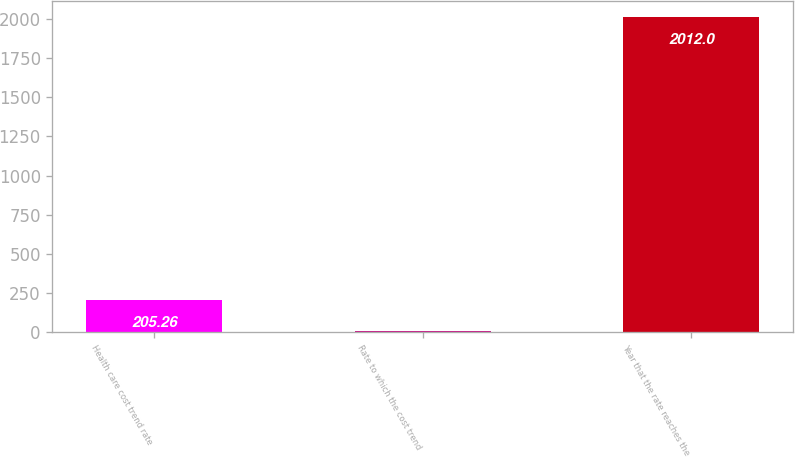Convert chart to OTSL. <chart><loc_0><loc_0><loc_500><loc_500><bar_chart><fcel>Health care cost trend rate<fcel>Rate to which the cost trend<fcel>Year that the rate reaches the<nl><fcel>205.26<fcel>4.51<fcel>2012<nl></chart> 